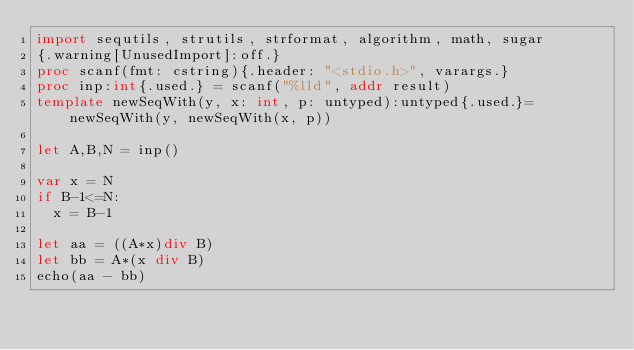Convert code to text. <code><loc_0><loc_0><loc_500><loc_500><_Nim_>import sequtils, strutils, strformat, algorithm, math, sugar
{.warning[UnusedImport]:off.}
proc scanf(fmt: cstring){.header: "<stdio.h>", varargs.}
proc inp:int{.used.} = scanf("%lld", addr result)
template newSeqWith(y, x: int, p: untyped):untyped{.used.}= newSeqWith(y, newSeqWith(x, p))

let A,B,N = inp()

var x = N
if B-1<=N:
  x = B-1

let aa = ((A*x)div B)
let bb = A*(x div B)
echo(aa - bb)</code> 